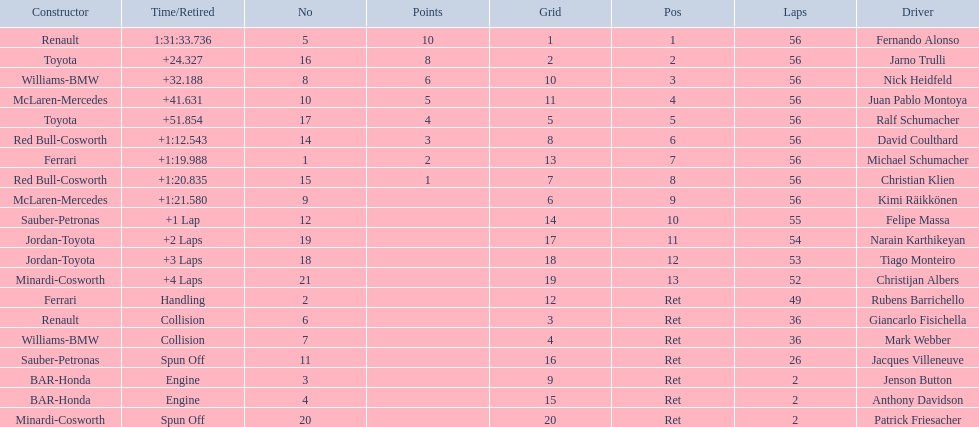Who was the last driver from the uk to actually finish the 56 laps? David Coulthard. 